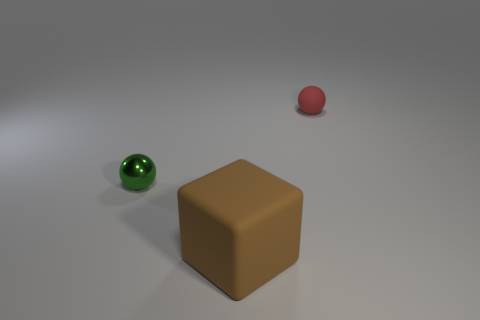Add 1 shiny spheres. How many objects exist? 4 Subtract all balls. How many objects are left? 1 Subtract all tiny green balls. Subtract all brown things. How many objects are left? 1 Add 3 metallic things. How many metallic things are left? 4 Add 2 rubber objects. How many rubber objects exist? 4 Subtract 0 purple balls. How many objects are left? 3 